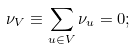<formula> <loc_0><loc_0><loc_500><loc_500>\nu _ { V } \equiv \sum _ { u \in V } \nu _ { u } = 0 ;</formula> 